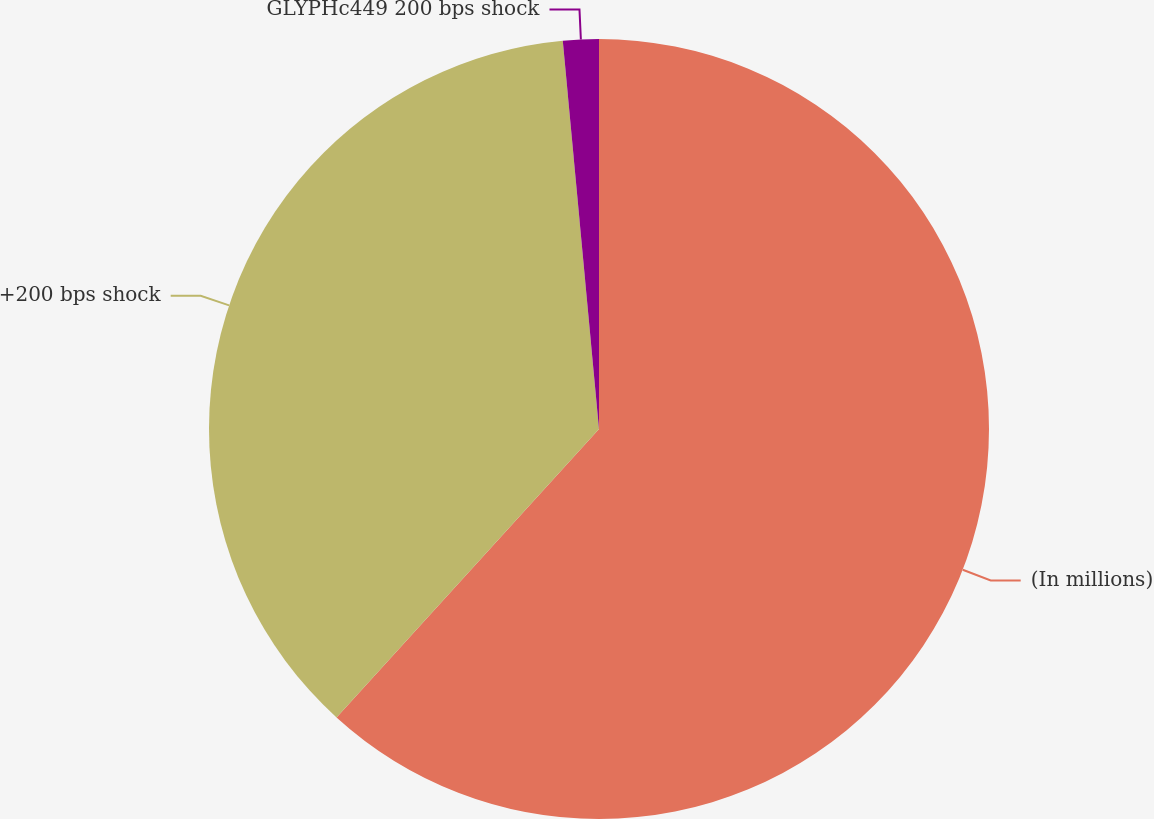Convert chart. <chart><loc_0><loc_0><loc_500><loc_500><pie_chart><fcel>(In millions)<fcel>+200 bps shock<fcel>GLYPHc449 200 bps shock<nl><fcel>61.75%<fcel>36.77%<fcel>1.48%<nl></chart> 